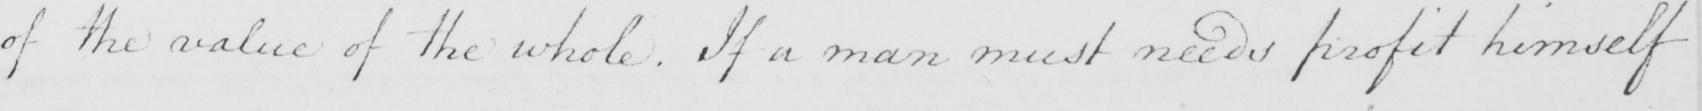Transcribe the text shown in this historical manuscript line. of the value of the whole . If a man must needs profit himself 